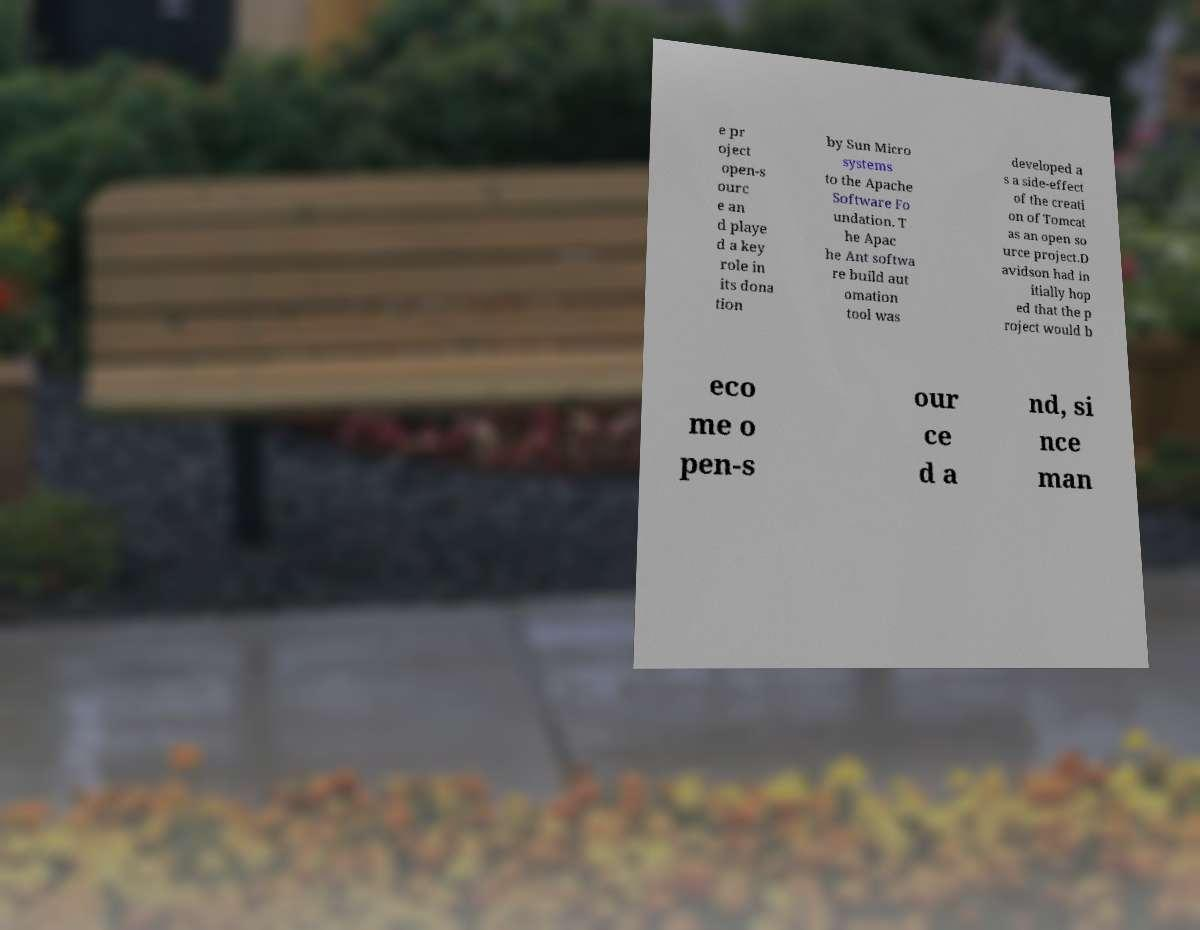For documentation purposes, I need the text within this image transcribed. Could you provide that? e pr oject open-s ourc e an d playe d a key role in its dona tion by Sun Micro systems to the Apache Software Fo undation. T he Apac he Ant softwa re build aut omation tool was developed a s a side-effect of the creati on of Tomcat as an open so urce project.D avidson had in itially hop ed that the p roject would b eco me o pen-s our ce d a nd, si nce man 